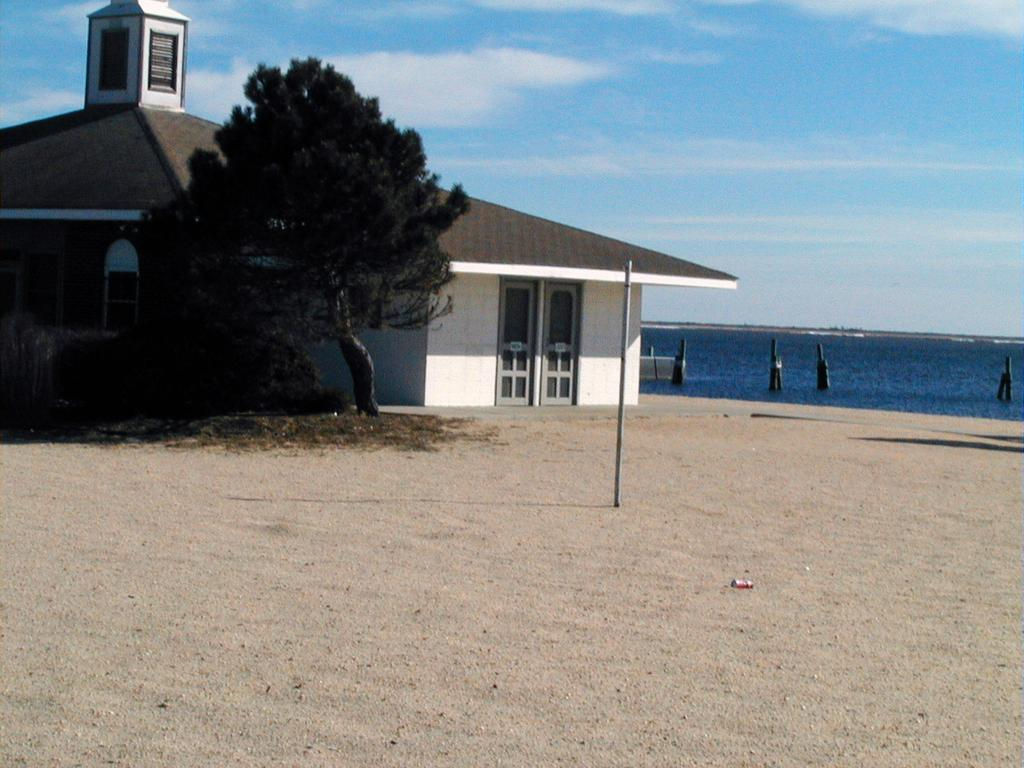What structure is located in the center of the image? There is a shed in the center of the image. What else is located in the center of the image? There is a tree in the center of the image. What can be seen on the right side of the image? There is water on the right side of the image. What is visible in the background of the image? The sky is visible in the background of the image. Where is the tin located in the image? There is no tin present in the image. What type of field can be seen in the image? There is no field present in the image. 